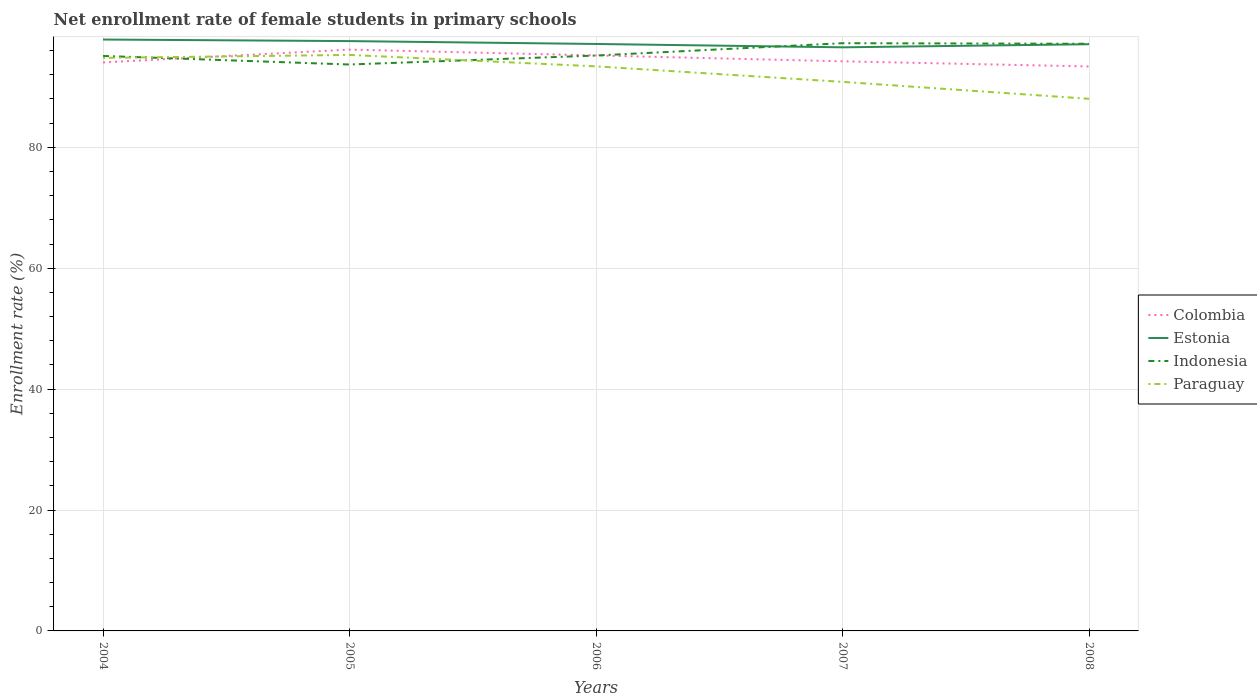Does the line corresponding to Paraguay intersect with the line corresponding to Indonesia?
Keep it short and to the point. Yes. Across all years, what is the maximum net enrollment rate of female students in primary schools in Colombia?
Offer a terse response. 93.38. In which year was the net enrollment rate of female students in primary schools in Paraguay maximum?
Offer a very short reply. 2008. What is the total net enrollment rate of female students in primary schools in Paraguay in the graph?
Your answer should be compact. -0.49. What is the difference between the highest and the second highest net enrollment rate of female students in primary schools in Estonia?
Provide a succinct answer. 1.29. What is the difference between the highest and the lowest net enrollment rate of female students in primary schools in Paraguay?
Ensure brevity in your answer.  3. How many lines are there?
Your response must be concise. 4. How many years are there in the graph?
Keep it short and to the point. 5. What is the difference between two consecutive major ticks on the Y-axis?
Keep it short and to the point. 20. Are the values on the major ticks of Y-axis written in scientific E-notation?
Give a very brief answer. No. Where does the legend appear in the graph?
Offer a very short reply. Center right. How many legend labels are there?
Your answer should be compact. 4. How are the legend labels stacked?
Provide a short and direct response. Vertical. What is the title of the graph?
Ensure brevity in your answer.  Net enrollment rate of female students in primary schools. What is the label or title of the X-axis?
Make the answer very short. Years. What is the label or title of the Y-axis?
Make the answer very short. Enrollment rate (%). What is the Enrollment rate (%) in Colombia in 2004?
Your answer should be compact. 94.05. What is the Enrollment rate (%) in Estonia in 2004?
Make the answer very short. 97.83. What is the Enrollment rate (%) of Indonesia in 2004?
Your answer should be compact. 95.12. What is the Enrollment rate (%) of Paraguay in 2004?
Make the answer very short. 94.8. What is the Enrollment rate (%) in Colombia in 2005?
Ensure brevity in your answer.  96.17. What is the Enrollment rate (%) in Estonia in 2005?
Your answer should be compact. 97.58. What is the Enrollment rate (%) in Indonesia in 2005?
Your answer should be very brief. 93.7. What is the Enrollment rate (%) of Paraguay in 2005?
Provide a short and direct response. 95.29. What is the Enrollment rate (%) of Colombia in 2006?
Ensure brevity in your answer.  95.2. What is the Enrollment rate (%) of Estonia in 2006?
Give a very brief answer. 97.1. What is the Enrollment rate (%) in Indonesia in 2006?
Your answer should be very brief. 95.19. What is the Enrollment rate (%) of Paraguay in 2006?
Give a very brief answer. 93.4. What is the Enrollment rate (%) in Colombia in 2007?
Keep it short and to the point. 94.23. What is the Enrollment rate (%) of Estonia in 2007?
Ensure brevity in your answer.  96.55. What is the Enrollment rate (%) in Indonesia in 2007?
Make the answer very short. 97.23. What is the Enrollment rate (%) of Paraguay in 2007?
Offer a very short reply. 90.83. What is the Enrollment rate (%) of Colombia in 2008?
Your answer should be compact. 93.38. What is the Enrollment rate (%) of Estonia in 2008?
Keep it short and to the point. 97.06. What is the Enrollment rate (%) in Indonesia in 2008?
Your answer should be compact. 97.13. What is the Enrollment rate (%) of Paraguay in 2008?
Give a very brief answer. 88.03. Across all years, what is the maximum Enrollment rate (%) in Colombia?
Make the answer very short. 96.17. Across all years, what is the maximum Enrollment rate (%) of Estonia?
Keep it short and to the point. 97.83. Across all years, what is the maximum Enrollment rate (%) of Indonesia?
Make the answer very short. 97.23. Across all years, what is the maximum Enrollment rate (%) of Paraguay?
Give a very brief answer. 95.29. Across all years, what is the minimum Enrollment rate (%) in Colombia?
Provide a short and direct response. 93.38. Across all years, what is the minimum Enrollment rate (%) in Estonia?
Offer a very short reply. 96.55. Across all years, what is the minimum Enrollment rate (%) in Indonesia?
Your answer should be very brief. 93.7. Across all years, what is the minimum Enrollment rate (%) in Paraguay?
Give a very brief answer. 88.03. What is the total Enrollment rate (%) in Colombia in the graph?
Your response must be concise. 473.03. What is the total Enrollment rate (%) in Estonia in the graph?
Your answer should be compact. 486.12. What is the total Enrollment rate (%) in Indonesia in the graph?
Your answer should be very brief. 478.37. What is the total Enrollment rate (%) in Paraguay in the graph?
Your answer should be compact. 462.34. What is the difference between the Enrollment rate (%) of Colombia in 2004 and that in 2005?
Your answer should be compact. -2.12. What is the difference between the Enrollment rate (%) in Estonia in 2004 and that in 2005?
Your response must be concise. 0.26. What is the difference between the Enrollment rate (%) in Indonesia in 2004 and that in 2005?
Give a very brief answer. 1.42. What is the difference between the Enrollment rate (%) of Paraguay in 2004 and that in 2005?
Your answer should be very brief. -0.49. What is the difference between the Enrollment rate (%) of Colombia in 2004 and that in 2006?
Offer a very short reply. -1.16. What is the difference between the Enrollment rate (%) of Estonia in 2004 and that in 2006?
Your response must be concise. 0.73. What is the difference between the Enrollment rate (%) in Indonesia in 2004 and that in 2006?
Your response must be concise. -0.07. What is the difference between the Enrollment rate (%) in Paraguay in 2004 and that in 2006?
Your answer should be compact. 1.4. What is the difference between the Enrollment rate (%) of Colombia in 2004 and that in 2007?
Offer a terse response. -0.18. What is the difference between the Enrollment rate (%) in Estonia in 2004 and that in 2007?
Make the answer very short. 1.29. What is the difference between the Enrollment rate (%) in Indonesia in 2004 and that in 2007?
Your answer should be very brief. -2.11. What is the difference between the Enrollment rate (%) in Paraguay in 2004 and that in 2007?
Your response must be concise. 3.97. What is the difference between the Enrollment rate (%) of Colombia in 2004 and that in 2008?
Offer a very short reply. 0.67. What is the difference between the Enrollment rate (%) in Estonia in 2004 and that in 2008?
Your response must be concise. 0.77. What is the difference between the Enrollment rate (%) in Indonesia in 2004 and that in 2008?
Your response must be concise. -2.01. What is the difference between the Enrollment rate (%) of Paraguay in 2004 and that in 2008?
Provide a short and direct response. 6.77. What is the difference between the Enrollment rate (%) in Colombia in 2005 and that in 2006?
Ensure brevity in your answer.  0.97. What is the difference between the Enrollment rate (%) of Estonia in 2005 and that in 2006?
Offer a terse response. 0.47. What is the difference between the Enrollment rate (%) in Indonesia in 2005 and that in 2006?
Give a very brief answer. -1.49. What is the difference between the Enrollment rate (%) in Paraguay in 2005 and that in 2006?
Provide a short and direct response. 1.89. What is the difference between the Enrollment rate (%) in Colombia in 2005 and that in 2007?
Make the answer very short. 1.94. What is the difference between the Enrollment rate (%) of Estonia in 2005 and that in 2007?
Ensure brevity in your answer.  1.03. What is the difference between the Enrollment rate (%) of Indonesia in 2005 and that in 2007?
Your answer should be very brief. -3.53. What is the difference between the Enrollment rate (%) in Paraguay in 2005 and that in 2007?
Make the answer very short. 4.46. What is the difference between the Enrollment rate (%) in Colombia in 2005 and that in 2008?
Provide a succinct answer. 2.79. What is the difference between the Enrollment rate (%) of Estonia in 2005 and that in 2008?
Ensure brevity in your answer.  0.52. What is the difference between the Enrollment rate (%) in Indonesia in 2005 and that in 2008?
Offer a terse response. -3.43. What is the difference between the Enrollment rate (%) of Paraguay in 2005 and that in 2008?
Give a very brief answer. 7.26. What is the difference between the Enrollment rate (%) in Colombia in 2006 and that in 2007?
Provide a short and direct response. 0.97. What is the difference between the Enrollment rate (%) in Estonia in 2006 and that in 2007?
Give a very brief answer. 0.55. What is the difference between the Enrollment rate (%) of Indonesia in 2006 and that in 2007?
Offer a very short reply. -2.04. What is the difference between the Enrollment rate (%) of Paraguay in 2006 and that in 2007?
Offer a very short reply. 2.57. What is the difference between the Enrollment rate (%) in Colombia in 2006 and that in 2008?
Keep it short and to the point. 1.82. What is the difference between the Enrollment rate (%) in Estonia in 2006 and that in 2008?
Provide a succinct answer. 0.04. What is the difference between the Enrollment rate (%) of Indonesia in 2006 and that in 2008?
Give a very brief answer. -1.94. What is the difference between the Enrollment rate (%) in Paraguay in 2006 and that in 2008?
Offer a very short reply. 5.37. What is the difference between the Enrollment rate (%) in Colombia in 2007 and that in 2008?
Your response must be concise. 0.85. What is the difference between the Enrollment rate (%) in Estonia in 2007 and that in 2008?
Keep it short and to the point. -0.51. What is the difference between the Enrollment rate (%) in Indonesia in 2007 and that in 2008?
Offer a terse response. 0.1. What is the difference between the Enrollment rate (%) of Paraguay in 2007 and that in 2008?
Make the answer very short. 2.8. What is the difference between the Enrollment rate (%) of Colombia in 2004 and the Enrollment rate (%) of Estonia in 2005?
Give a very brief answer. -3.53. What is the difference between the Enrollment rate (%) of Colombia in 2004 and the Enrollment rate (%) of Indonesia in 2005?
Give a very brief answer. 0.34. What is the difference between the Enrollment rate (%) of Colombia in 2004 and the Enrollment rate (%) of Paraguay in 2005?
Your response must be concise. -1.24. What is the difference between the Enrollment rate (%) of Estonia in 2004 and the Enrollment rate (%) of Indonesia in 2005?
Your answer should be compact. 4.13. What is the difference between the Enrollment rate (%) in Estonia in 2004 and the Enrollment rate (%) in Paraguay in 2005?
Make the answer very short. 2.54. What is the difference between the Enrollment rate (%) of Indonesia in 2004 and the Enrollment rate (%) of Paraguay in 2005?
Give a very brief answer. -0.17. What is the difference between the Enrollment rate (%) of Colombia in 2004 and the Enrollment rate (%) of Estonia in 2006?
Offer a very short reply. -3.05. What is the difference between the Enrollment rate (%) of Colombia in 2004 and the Enrollment rate (%) of Indonesia in 2006?
Keep it short and to the point. -1.14. What is the difference between the Enrollment rate (%) of Colombia in 2004 and the Enrollment rate (%) of Paraguay in 2006?
Your answer should be compact. 0.65. What is the difference between the Enrollment rate (%) of Estonia in 2004 and the Enrollment rate (%) of Indonesia in 2006?
Provide a succinct answer. 2.65. What is the difference between the Enrollment rate (%) in Estonia in 2004 and the Enrollment rate (%) in Paraguay in 2006?
Offer a terse response. 4.44. What is the difference between the Enrollment rate (%) of Indonesia in 2004 and the Enrollment rate (%) of Paraguay in 2006?
Ensure brevity in your answer.  1.72. What is the difference between the Enrollment rate (%) in Colombia in 2004 and the Enrollment rate (%) in Estonia in 2007?
Ensure brevity in your answer.  -2.5. What is the difference between the Enrollment rate (%) of Colombia in 2004 and the Enrollment rate (%) of Indonesia in 2007?
Your answer should be compact. -3.18. What is the difference between the Enrollment rate (%) in Colombia in 2004 and the Enrollment rate (%) in Paraguay in 2007?
Make the answer very short. 3.22. What is the difference between the Enrollment rate (%) in Estonia in 2004 and the Enrollment rate (%) in Indonesia in 2007?
Give a very brief answer. 0.61. What is the difference between the Enrollment rate (%) of Estonia in 2004 and the Enrollment rate (%) of Paraguay in 2007?
Provide a short and direct response. 7. What is the difference between the Enrollment rate (%) of Indonesia in 2004 and the Enrollment rate (%) of Paraguay in 2007?
Provide a succinct answer. 4.29. What is the difference between the Enrollment rate (%) of Colombia in 2004 and the Enrollment rate (%) of Estonia in 2008?
Ensure brevity in your answer.  -3.01. What is the difference between the Enrollment rate (%) of Colombia in 2004 and the Enrollment rate (%) of Indonesia in 2008?
Keep it short and to the point. -3.09. What is the difference between the Enrollment rate (%) in Colombia in 2004 and the Enrollment rate (%) in Paraguay in 2008?
Your response must be concise. 6.02. What is the difference between the Enrollment rate (%) in Estonia in 2004 and the Enrollment rate (%) in Indonesia in 2008?
Make the answer very short. 0.7. What is the difference between the Enrollment rate (%) in Estonia in 2004 and the Enrollment rate (%) in Paraguay in 2008?
Keep it short and to the point. 9.8. What is the difference between the Enrollment rate (%) of Indonesia in 2004 and the Enrollment rate (%) of Paraguay in 2008?
Your answer should be very brief. 7.09. What is the difference between the Enrollment rate (%) of Colombia in 2005 and the Enrollment rate (%) of Estonia in 2006?
Your response must be concise. -0.93. What is the difference between the Enrollment rate (%) in Colombia in 2005 and the Enrollment rate (%) in Indonesia in 2006?
Offer a terse response. 0.98. What is the difference between the Enrollment rate (%) in Colombia in 2005 and the Enrollment rate (%) in Paraguay in 2006?
Make the answer very short. 2.77. What is the difference between the Enrollment rate (%) of Estonia in 2005 and the Enrollment rate (%) of Indonesia in 2006?
Your response must be concise. 2.39. What is the difference between the Enrollment rate (%) of Estonia in 2005 and the Enrollment rate (%) of Paraguay in 2006?
Keep it short and to the point. 4.18. What is the difference between the Enrollment rate (%) of Indonesia in 2005 and the Enrollment rate (%) of Paraguay in 2006?
Your answer should be compact. 0.31. What is the difference between the Enrollment rate (%) of Colombia in 2005 and the Enrollment rate (%) of Estonia in 2007?
Make the answer very short. -0.38. What is the difference between the Enrollment rate (%) in Colombia in 2005 and the Enrollment rate (%) in Indonesia in 2007?
Offer a terse response. -1.06. What is the difference between the Enrollment rate (%) of Colombia in 2005 and the Enrollment rate (%) of Paraguay in 2007?
Your answer should be very brief. 5.34. What is the difference between the Enrollment rate (%) of Estonia in 2005 and the Enrollment rate (%) of Indonesia in 2007?
Make the answer very short. 0.35. What is the difference between the Enrollment rate (%) in Estonia in 2005 and the Enrollment rate (%) in Paraguay in 2007?
Your response must be concise. 6.75. What is the difference between the Enrollment rate (%) of Indonesia in 2005 and the Enrollment rate (%) of Paraguay in 2007?
Provide a succinct answer. 2.87. What is the difference between the Enrollment rate (%) in Colombia in 2005 and the Enrollment rate (%) in Estonia in 2008?
Offer a terse response. -0.89. What is the difference between the Enrollment rate (%) of Colombia in 2005 and the Enrollment rate (%) of Indonesia in 2008?
Make the answer very short. -0.96. What is the difference between the Enrollment rate (%) in Colombia in 2005 and the Enrollment rate (%) in Paraguay in 2008?
Your answer should be very brief. 8.14. What is the difference between the Enrollment rate (%) in Estonia in 2005 and the Enrollment rate (%) in Indonesia in 2008?
Provide a succinct answer. 0.44. What is the difference between the Enrollment rate (%) in Estonia in 2005 and the Enrollment rate (%) in Paraguay in 2008?
Ensure brevity in your answer.  9.55. What is the difference between the Enrollment rate (%) of Indonesia in 2005 and the Enrollment rate (%) of Paraguay in 2008?
Provide a succinct answer. 5.67. What is the difference between the Enrollment rate (%) of Colombia in 2006 and the Enrollment rate (%) of Estonia in 2007?
Your answer should be very brief. -1.35. What is the difference between the Enrollment rate (%) in Colombia in 2006 and the Enrollment rate (%) in Indonesia in 2007?
Give a very brief answer. -2.03. What is the difference between the Enrollment rate (%) of Colombia in 2006 and the Enrollment rate (%) of Paraguay in 2007?
Give a very brief answer. 4.37. What is the difference between the Enrollment rate (%) in Estonia in 2006 and the Enrollment rate (%) in Indonesia in 2007?
Give a very brief answer. -0.13. What is the difference between the Enrollment rate (%) of Estonia in 2006 and the Enrollment rate (%) of Paraguay in 2007?
Offer a very short reply. 6.27. What is the difference between the Enrollment rate (%) in Indonesia in 2006 and the Enrollment rate (%) in Paraguay in 2007?
Offer a very short reply. 4.36. What is the difference between the Enrollment rate (%) of Colombia in 2006 and the Enrollment rate (%) of Estonia in 2008?
Make the answer very short. -1.86. What is the difference between the Enrollment rate (%) of Colombia in 2006 and the Enrollment rate (%) of Indonesia in 2008?
Your answer should be very brief. -1.93. What is the difference between the Enrollment rate (%) of Colombia in 2006 and the Enrollment rate (%) of Paraguay in 2008?
Keep it short and to the point. 7.17. What is the difference between the Enrollment rate (%) of Estonia in 2006 and the Enrollment rate (%) of Indonesia in 2008?
Provide a succinct answer. -0.03. What is the difference between the Enrollment rate (%) of Estonia in 2006 and the Enrollment rate (%) of Paraguay in 2008?
Provide a short and direct response. 9.07. What is the difference between the Enrollment rate (%) in Indonesia in 2006 and the Enrollment rate (%) in Paraguay in 2008?
Offer a very short reply. 7.16. What is the difference between the Enrollment rate (%) of Colombia in 2007 and the Enrollment rate (%) of Estonia in 2008?
Offer a very short reply. -2.83. What is the difference between the Enrollment rate (%) of Colombia in 2007 and the Enrollment rate (%) of Indonesia in 2008?
Provide a short and direct response. -2.9. What is the difference between the Enrollment rate (%) in Colombia in 2007 and the Enrollment rate (%) in Paraguay in 2008?
Offer a terse response. 6.2. What is the difference between the Enrollment rate (%) in Estonia in 2007 and the Enrollment rate (%) in Indonesia in 2008?
Provide a succinct answer. -0.58. What is the difference between the Enrollment rate (%) in Estonia in 2007 and the Enrollment rate (%) in Paraguay in 2008?
Keep it short and to the point. 8.52. What is the difference between the Enrollment rate (%) of Indonesia in 2007 and the Enrollment rate (%) of Paraguay in 2008?
Provide a short and direct response. 9.2. What is the average Enrollment rate (%) of Colombia per year?
Offer a very short reply. 94.61. What is the average Enrollment rate (%) in Estonia per year?
Provide a succinct answer. 97.22. What is the average Enrollment rate (%) in Indonesia per year?
Make the answer very short. 95.67. What is the average Enrollment rate (%) in Paraguay per year?
Your answer should be compact. 92.47. In the year 2004, what is the difference between the Enrollment rate (%) of Colombia and Enrollment rate (%) of Estonia?
Provide a short and direct response. -3.79. In the year 2004, what is the difference between the Enrollment rate (%) in Colombia and Enrollment rate (%) in Indonesia?
Your response must be concise. -1.07. In the year 2004, what is the difference between the Enrollment rate (%) of Colombia and Enrollment rate (%) of Paraguay?
Give a very brief answer. -0.75. In the year 2004, what is the difference between the Enrollment rate (%) in Estonia and Enrollment rate (%) in Indonesia?
Your answer should be compact. 2.71. In the year 2004, what is the difference between the Enrollment rate (%) of Estonia and Enrollment rate (%) of Paraguay?
Offer a terse response. 3.03. In the year 2004, what is the difference between the Enrollment rate (%) in Indonesia and Enrollment rate (%) in Paraguay?
Offer a very short reply. 0.32. In the year 2005, what is the difference between the Enrollment rate (%) in Colombia and Enrollment rate (%) in Estonia?
Provide a succinct answer. -1.41. In the year 2005, what is the difference between the Enrollment rate (%) of Colombia and Enrollment rate (%) of Indonesia?
Your answer should be very brief. 2.47. In the year 2005, what is the difference between the Enrollment rate (%) in Colombia and Enrollment rate (%) in Paraguay?
Ensure brevity in your answer.  0.88. In the year 2005, what is the difference between the Enrollment rate (%) of Estonia and Enrollment rate (%) of Indonesia?
Your response must be concise. 3.87. In the year 2005, what is the difference between the Enrollment rate (%) of Estonia and Enrollment rate (%) of Paraguay?
Provide a short and direct response. 2.29. In the year 2005, what is the difference between the Enrollment rate (%) of Indonesia and Enrollment rate (%) of Paraguay?
Provide a succinct answer. -1.59. In the year 2006, what is the difference between the Enrollment rate (%) of Colombia and Enrollment rate (%) of Estonia?
Your answer should be very brief. -1.9. In the year 2006, what is the difference between the Enrollment rate (%) of Colombia and Enrollment rate (%) of Indonesia?
Keep it short and to the point. 0.01. In the year 2006, what is the difference between the Enrollment rate (%) of Colombia and Enrollment rate (%) of Paraguay?
Make the answer very short. 1.81. In the year 2006, what is the difference between the Enrollment rate (%) of Estonia and Enrollment rate (%) of Indonesia?
Give a very brief answer. 1.91. In the year 2006, what is the difference between the Enrollment rate (%) of Estonia and Enrollment rate (%) of Paraguay?
Give a very brief answer. 3.7. In the year 2006, what is the difference between the Enrollment rate (%) of Indonesia and Enrollment rate (%) of Paraguay?
Offer a very short reply. 1.79. In the year 2007, what is the difference between the Enrollment rate (%) in Colombia and Enrollment rate (%) in Estonia?
Offer a very short reply. -2.32. In the year 2007, what is the difference between the Enrollment rate (%) of Colombia and Enrollment rate (%) of Indonesia?
Give a very brief answer. -3. In the year 2007, what is the difference between the Enrollment rate (%) of Colombia and Enrollment rate (%) of Paraguay?
Offer a terse response. 3.4. In the year 2007, what is the difference between the Enrollment rate (%) of Estonia and Enrollment rate (%) of Indonesia?
Provide a short and direct response. -0.68. In the year 2007, what is the difference between the Enrollment rate (%) in Estonia and Enrollment rate (%) in Paraguay?
Your response must be concise. 5.72. In the year 2007, what is the difference between the Enrollment rate (%) of Indonesia and Enrollment rate (%) of Paraguay?
Offer a terse response. 6.4. In the year 2008, what is the difference between the Enrollment rate (%) of Colombia and Enrollment rate (%) of Estonia?
Your response must be concise. -3.68. In the year 2008, what is the difference between the Enrollment rate (%) in Colombia and Enrollment rate (%) in Indonesia?
Your answer should be very brief. -3.75. In the year 2008, what is the difference between the Enrollment rate (%) in Colombia and Enrollment rate (%) in Paraguay?
Your answer should be very brief. 5.35. In the year 2008, what is the difference between the Enrollment rate (%) of Estonia and Enrollment rate (%) of Indonesia?
Keep it short and to the point. -0.07. In the year 2008, what is the difference between the Enrollment rate (%) of Estonia and Enrollment rate (%) of Paraguay?
Offer a very short reply. 9.03. In the year 2008, what is the difference between the Enrollment rate (%) in Indonesia and Enrollment rate (%) in Paraguay?
Provide a short and direct response. 9.1. What is the ratio of the Enrollment rate (%) of Colombia in 2004 to that in 2005?
Your answer should be compact. 0.98. What is the ratio of the Enrollment rate (%) in Indonesia in 2004 to that in 2005?
Provide a short and direct response. 1.02. What is the ratio of the Enrollment rate (%) in Paraguay in 2004 to that in 2005?
Give a very brief answer. 0.99. What is the ratio of the Enrollment rate (%) in Colombia in 2004 to that in 2006?
Ensure brevity in your answer.  0.99. What is the ratio of the Enrollment rate (%) of Estonia in 2004 to that in 2006?
Offer a very short reply. 1.01. What is the ratio of the Enrollment rate (%) of Paraguay in 2004 to that in 2006?
Your response must be concise. 1.01. What is the ratio of the Enrollment rate (%) of Colombia in 2004 to that in 2007?
Your response must be concise. 1. What is the ratio of the Enrollment rate (%) in Estonia in 2004 to that in 2007?
Offer a very short reply. 1.01. What is the ratio of the Enrollment rate (%) of Indonesia in 2004 to that in 2007?
Keep it short and to the point. 0.98. What is the ratio of the Enrollment rate (%) of Paraguay in 2004 to that in 2007?
Provide a short and direct response. 1.04. What is the ratio of the Enrollment rate (%) of Colombia in 2004 to that in 2008?
Provide a succinct answer. 1.01. What is the ratio of the Enrollment rate (%) in Estonia in 2004 to that in 2008?
Ensure brevity in your answer.  1.01. What is the ratio of the Enrollment rate (%) in Indonesia in 2004 to that in 2008?
Offer a terse response. 0.98. What is the ratio of the Enrollment rate (%) of Paraguay in 2004 to that in 2008?
Give a very brief answer. 1.08. What is the ratio of the Enrollment rate (%) in Colombia in 2005 to that in 2006?
Give a very brief answer. 1.01. What is the ratio of the Enrollment rate (%) in Indonesia in 2005 to that in 2006?
Make the answer very short. 0.98. What is the ratio of the Enrollment rate (%) in Paraguay in 2005 to that in 2006?
Keep it short and to the point. 1.02. What is the ratio of the Enrollment rate (%) of Colombia in 2005 to that in 2007?
Make the answer very short. 1.02. What is the ratio of the Enrollment rate (%) of Estonia in 2005 to that in 2007?
Offer a terse response. 1.01. What is the ratio of the Enrollment rate (%) of Indonesia in 2005 to that in 2007?
Your answer should be compact. 0.96. What is the ratio of the Enrollment rate (%) in Paraguay in 2005 to that in 2007?
Ensure brevity in your answer.  1.05. What is the ratio of the Enrollment rate (%) of Colombia in 2005 to that in 2008?
Keep it short and to the point. 1.03. What is the ratio of the Enrollment rate (%) of Estonia in 2005 to that in 2008?
Your answer should be compact. 1.01. What is the ratio of the Enrollment rate (%) of Indonesia in 2005 to that in 2008?
Your response must be concise. 0.96. What is the ratio of the Enrollment rate (%) in Paraguay in 2005 to that in 2008?
Offer a very short reply. 1.08. What is the ratio of the Enrollment rate (%) of Colombia in 2006 to that in 2007?
Give a very brief answer. 1.01. What is the ratio of the Enrollment rate (%) in Paraguay in 2006 to that in 2007?
Provide a short and direct response. 1.03. What is the ratio of the Enrollment rate (%) of Colombia in 2006 to that in 2008?
Your answer should be very brief. 1.02. What is the ratio of the Enrollment rate (%) in Estonia in 2006 to that in 2008?
Make the answer very short. 1. What is the ratio of the Enrollment rate (%) in Paraguay in 2006 to that in 2008?
Offer a terse response. 1.06. What is the ratio of the Enrollment rate (%) in Colombia in 2007 to that in 2008?
Offer a terse response. 1.01. What is the ratio of the Enrollment rate (%) in Paraguay in 2007 to that in 2008?
Keep it short and to the point. 1.03. What is the difference between the highest and the second highest Enrollment rate (%) of Colombia?
Keep it short and to the point. 0.97. What is the difference between the highest and the second highest Enrollment rate (%) of Estonia?
Provide a short and direct response. 0.26. What is the difference between the highest and the second highest Enrollment rate (%) in Indonesia?
Offer a very short reply. 0.1. What is the difference between the highest and the second highest Enrollment rate (%) of Paraguay?
Provide a succinct answer. 0.49. What is the difference between the highest and the lowest Enrollment rate (%) of Colombia?
Provide a succinct answer. 2.79. What is the difference between the highest and the lowest Enrollment rate (%) in Estonia?
Make the answer very short. 1.29. What is the difference between the highest and the lowest Enrollment rate (%) of Indonesia?
Offer a terse response. 3.53. What is the difference between the highest and the lowest Enrollment rate (%) in Paraguay?
Provide a short and direct response. 7.26. 